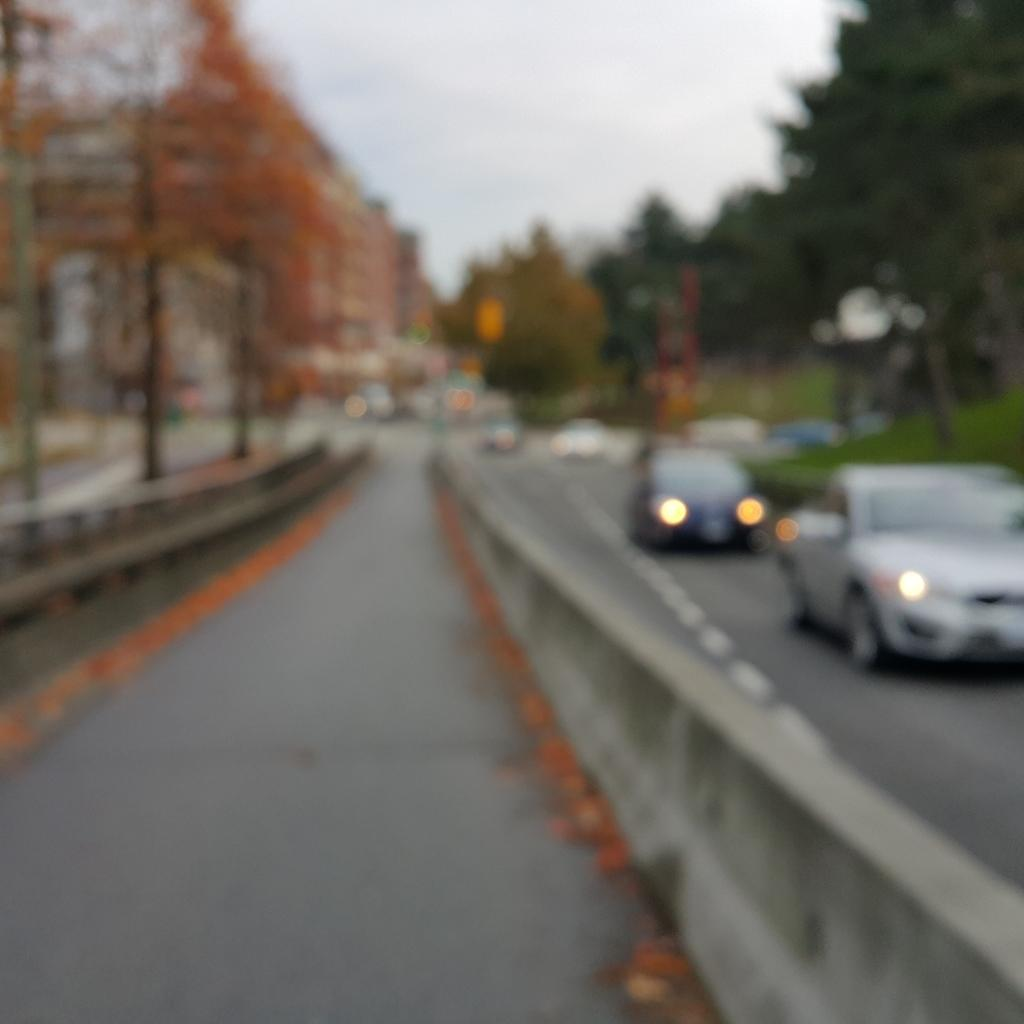What can be seen on the road in the image? There are vehicles on the road in the image. What separates the lanes of traffic in the image? There is a road divider in the image. What can be seen in the distance in the image? There are buildings, trees, and the sky visible in the background of the image. Where are the flowers growing in the wilderness in the image? There are no flowers or wilderness present in the image; it features vehicles on a road with a road divider and buildings, trees, and the sky in the background. 